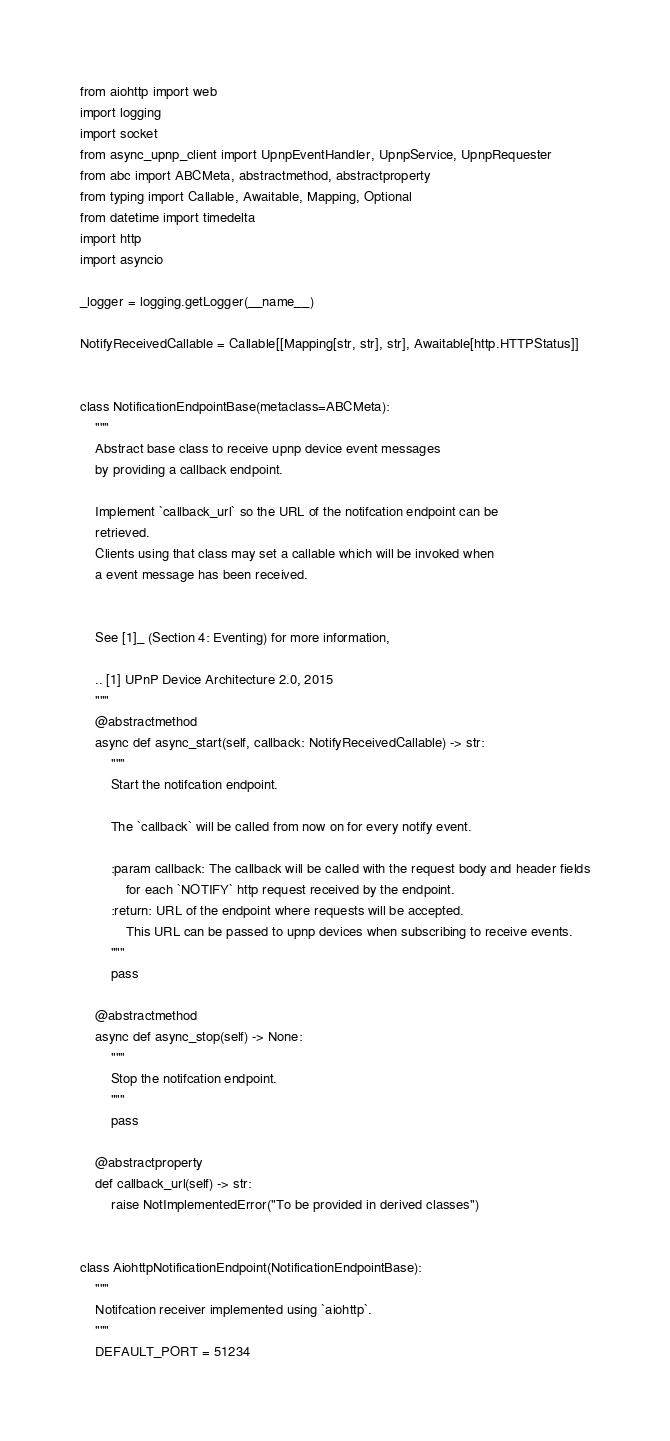<code> <loc_0><loc_0><loc_500><loc_500><_Python_>from aiohttp import web
import logging
import socket
from async_upnp_client import UpnpEventHandler, UpnpService, UpnpRequester
from abc import ABCMeta, abstractmethod, abstractproperty
from typing import Callable, Awaitable, Mapping, Optional
from datetime import timedelta
import http
import asyncio

_logger = logging.getLogger(__name__)

NotifyReceivedCallable = Callable[[Mapping[str, str], str], Awaitable[http.HTTPStatus]]


class NotificationEndpointBase(metaclass=ABCMeta):
    """
    Abstract base class to receive upnp device event messages
    by providing a callback endpoint.

    Implement `callback_url` so the URL of the notifcation endpoint can be
    retrieved.
    Clients using that class may set a callable which will be invoked when
    a event message has been received.


    See [1]_ (Section 4: Eventing) for more information,

    .. [1] UPnP Device Architecture 2.0, 2015
    """
    @abstractmethod
    async def async_start(self, callback: NotifyReceivedCallable) -> str:
        """
        Start the notifcation endpoint.

        The `callback` will be called from now on for every notify event.

        :param callback: The callback will be called with the request body and header fields
            for each `NOTIFY` http request received by the endpoint.
        :return: URL of the endpoint where requests will be accepted.
            This URL can be passed to upnp devices when subscribing to receive events.
        """
        pass

    @abstractmethod
    async def async_stop(self) -> None:
        """
        Stop the notifcation endpoint.
        """
        pass

    @abstractproperty
    def callback_url(self) -> str:
        raise NotImplementedError("To be provided in derived classes")


class AiohttpNotificationEndpoint(NotificationEndpointBase):
    """
    Notifcation receiver implemented using `aiohttp`.
    """
    DEFAULT_PORT = 51234
</code> 